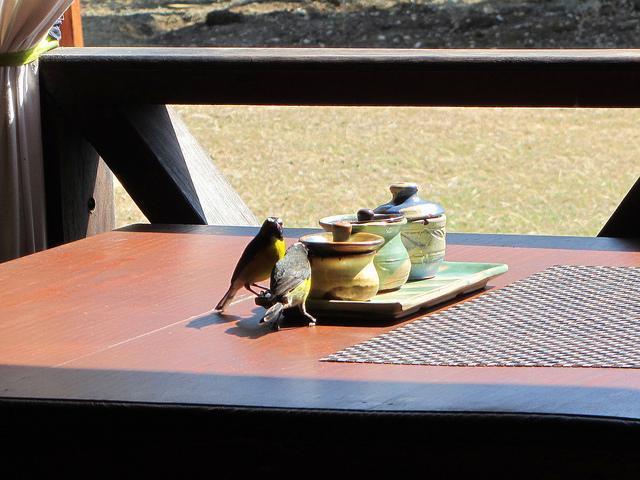How many birds are visible?
Give a very brief answer. 2. How many giraffes are standing?
Give a very brief answer. 0. 